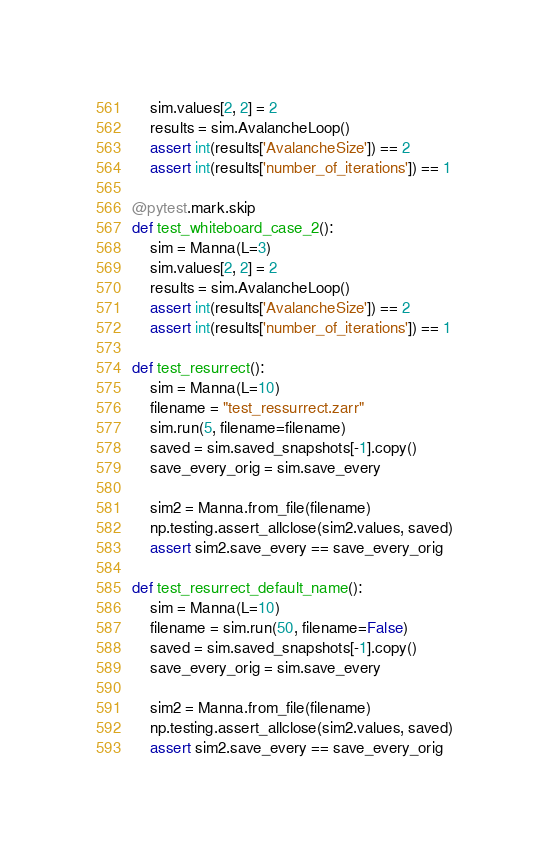Convert code to text. <code><loc_0><loc_0><loc_500><loc_500><_Python_>    sim.values[2, 2] = 2
    results = sim.AvalancheLoop()
    assert int(results['AvalancheSize']) == 2
    assert int(results['number_of_iterations']) == 1

@pytest.mark.skip
def test_whiteboard_case_2():
    sim = Manna(L=3)
    sim.values[2, 2] = 2
    results = sim.AvalancheLoop()
    assert int(results['AvalancheSize']) == 2
    assert int(results['number_of_iterations']) == 1

def test_resurrect():
    sim = Manna(L=10)
    filename = "test_ressurrect.zarr"
    sim.run(5, filename=filename)
    saved = sim.saved_snapshots[-1].copy()
    save_every_orig = sim.save_every

    sim2 = Manna.from_file(filename)
    np.testing.assert_allclose(sim2.values, saved)
    assert sim2.save_every == save_every_orig

def test_resurrect_default_name():
    sim = Manna(L=10)
    filename = sim.run(50, filename=False)
    saved = sim.saved_snapshots[-1].copy()
    save_every_orig = sim.save_every

    sim2 = Manna.from_file(filename)
    np.testing.assert_allclose(sim2.values, saved)
    assert sim2.save_every == save_every_orig
</code> 